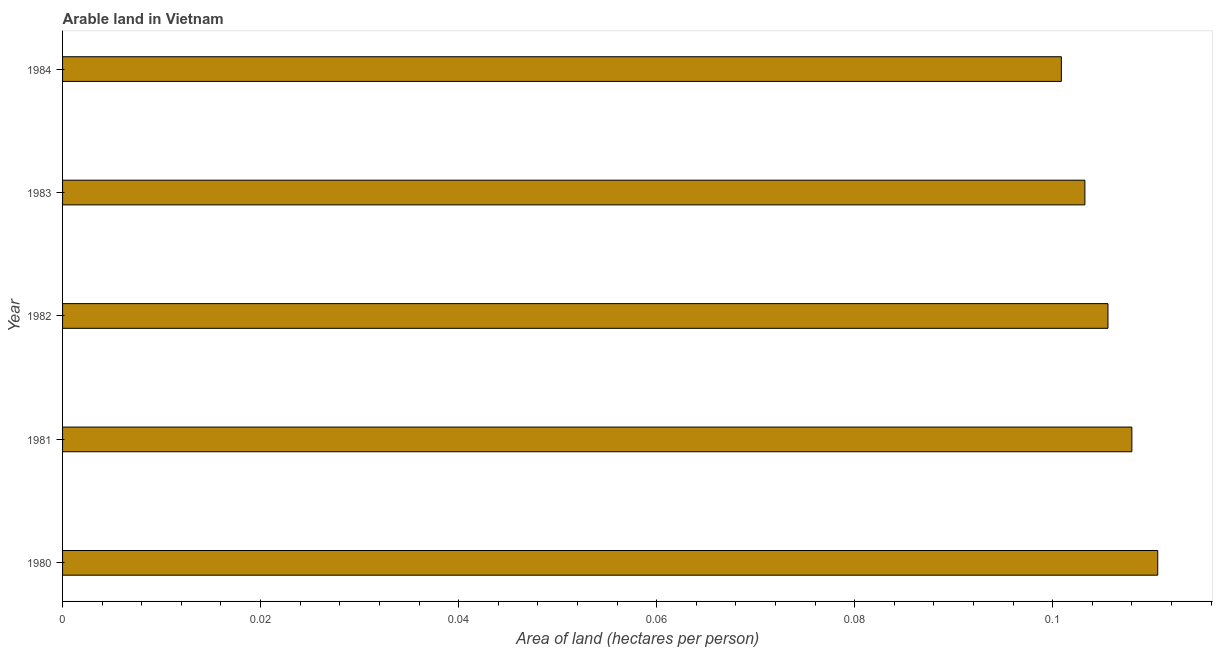What is the title of the graph?
Your response must be concise. Arable land in Vietnam. What is the label or title of the X-axis?
Give a very brief answer. Area of land (hectares per person). What is the area of arable land in 1981?
Make the answer very short. 0.11. Across all years, what is the maximum area of arable land?
Your response must be concise. 0.11. Across all years, what is the minimum area of arable land?
Offer a terse response. 0.1. What is the sum of the area of arable land?
Offer a terse response. 0.53. What is the difference between the area of arable land in 1981 and 1983?
Ensure brevity in your answer.  0.01. What is the average area of arable land per year?
Make the answer very short. 0.11. What is the median area of arable land?
Your answer should be very brief. 0.11. In how many years, is the area of arable land greater than 0.004 hectares per person?
Your answer should be compact. 5. What is the ratio of the area of arable land in 1980 to that in 1984?
Ensure brevity in your answer.  1.1. Is the area of arable land in 1980 less than that in 1984?
Your answer should be very brief. No. Is the difference between the area of arable land in 1980 and 1981 greater than the difference between any two years?
Ensure brevity in your answer.  No. What is the difference between the highest and the second highest area of arable land?
Provide a succinct answer. 0. In how many years, is the area of arable land greater than the average area of arable land taken over all years?
Offer a very short reply. 2. Are all the bars in the graph horizontal?
Your answer should be compact. Yes. What is the Area of land (hectares per person) of 1980?
Ensure brevity in your answer.  0.11. What is the Area of land (hectares per person) in 1981?
Your answer should be very brief. 0.11. What is the Area of land (hectares per person) in 1982?
Give a very brief answer. 0.11. What is the Area of land (hectares per person) in 1983?
Provide a short and direct response. 0.1. What is the Area of land (hectares per person) in 1984?
Make the answer very short. 0.1. What is the difference between the Area of land (hectares per person) in 1980 and 1981?
Your answer should be compact. 0. What is the difference between the Area of land (hectares per person) in 1980 and 1982?
Keep it short and to the point. 0.01. What is the difference between the Area of land (hectares per person) in 1980 and 1983?
Keep it short and to the point. 0.01. What is the difference between the Area of land (hectares per person) in 1980 and 1984?
Give a very brief answer. 0.01. What is the difference between the Area of land (hectares per person) in 1981 and 1982?
Provide a succinct answer. 0. What is the difference between the Area of land (hectares per person) in 1981 and 1983?
Keep it short and to the point. 0. What is the difference between the Area of land (hectares per person) in 1981 and 1984?
Your answer should be very brief. 0.01. What is the difference between the Area of land (hectares per person) in 1982 and 1983?
Your response must be concise. 0. What is the difference between the Area of land (hectares per person) in 1982 and 1984?
Offer a very short reply. 0. What is the difference between the Area of land (hectares per person) in 1983 and 1984?
Your answer should be very brief. 0. What is the ratio of the Area of land (hectares per person) in 1980 to that in 1982?
Your response must be concise. 1.05. What is the ratio of the Area of land (hectares per person) in 1980 to that in 1983?
Keep it short and to the point. 1.07. What is the ratio of the Area of land (hectares per person) in 1980 to that in 1984?
Your answer should be compact. 1.1. What is the ratio of the Area of land (hectares per person) in 1981 to that in 1982?
Make the answer very short. 1.02. What is the ratio of the Area of land (hectares per person) in 1981 to that in 1983?
Keep it short and to the point. 1.05. What is the ratio of the Area of land (hectares per person) in 1981 to that in 1984?
Offer a terse response. 1.07. What is the ratio of the Area of land (hectares per person) in 1982 to that in 1984?
Offer a very short reply. 1.05. What is the ratio of the Area of land (hectares per person) in 1983 to that in 1984?
Your answer should be very brief. 1.02. 